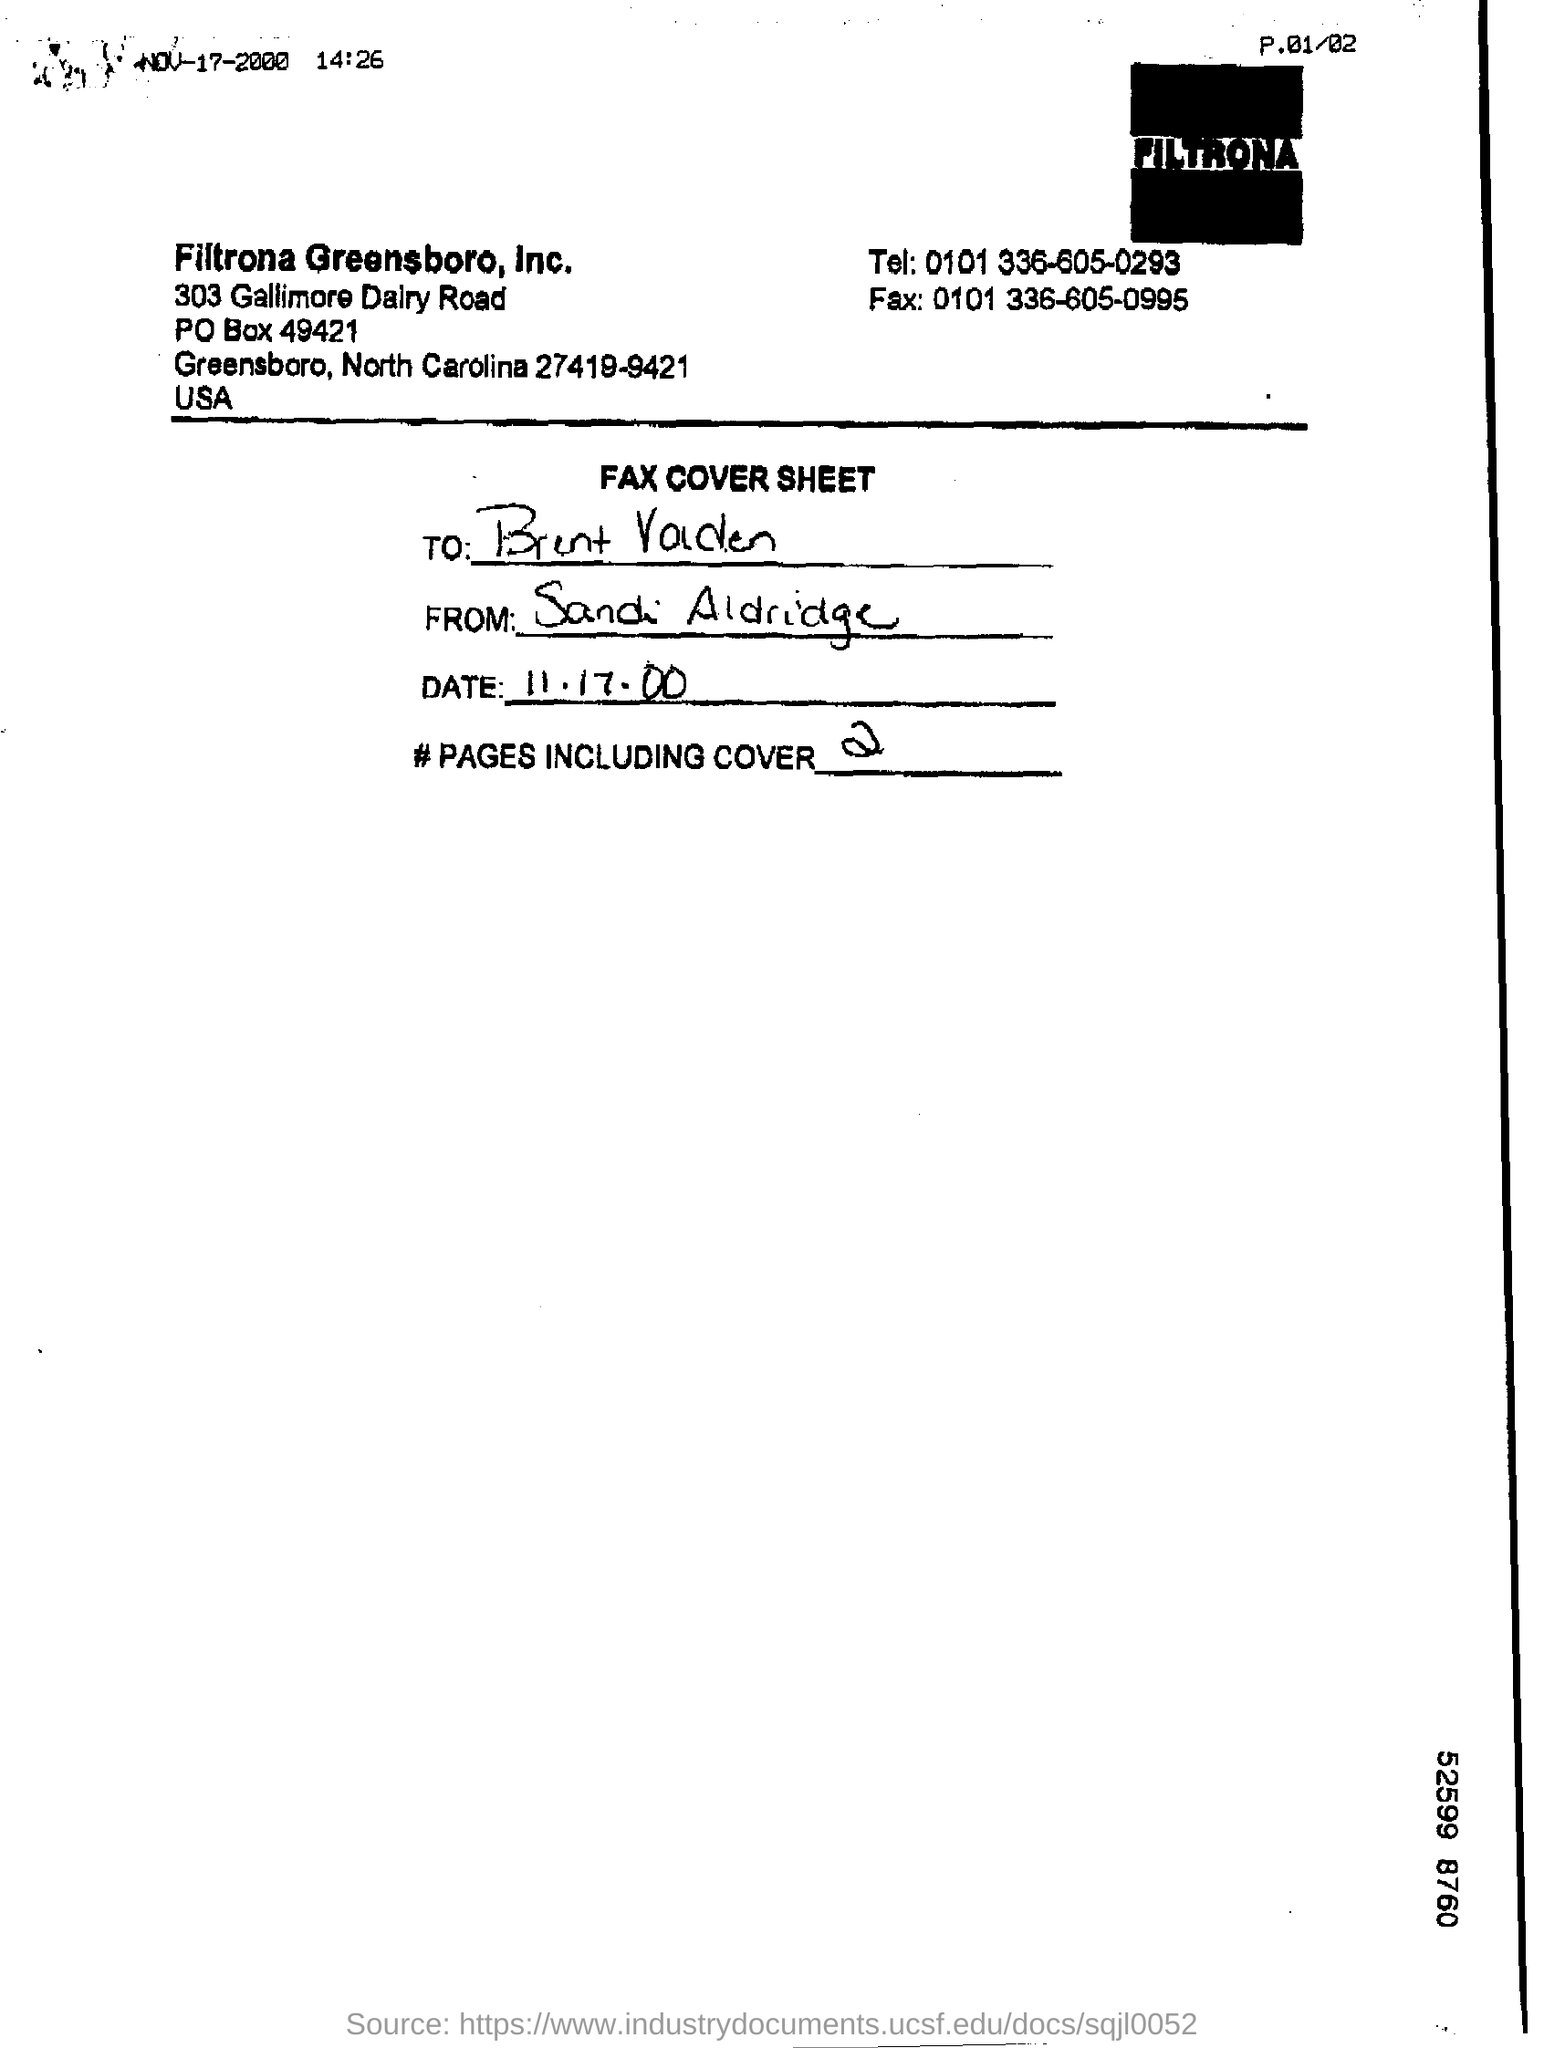Mention a couple of crucial points in this snapshot. The fax number provided is 0101 336-605-0995. This fax cover sheet belongs to Filtrona Greensboro, Inc. There are two pages in the fax, including the cover page. 